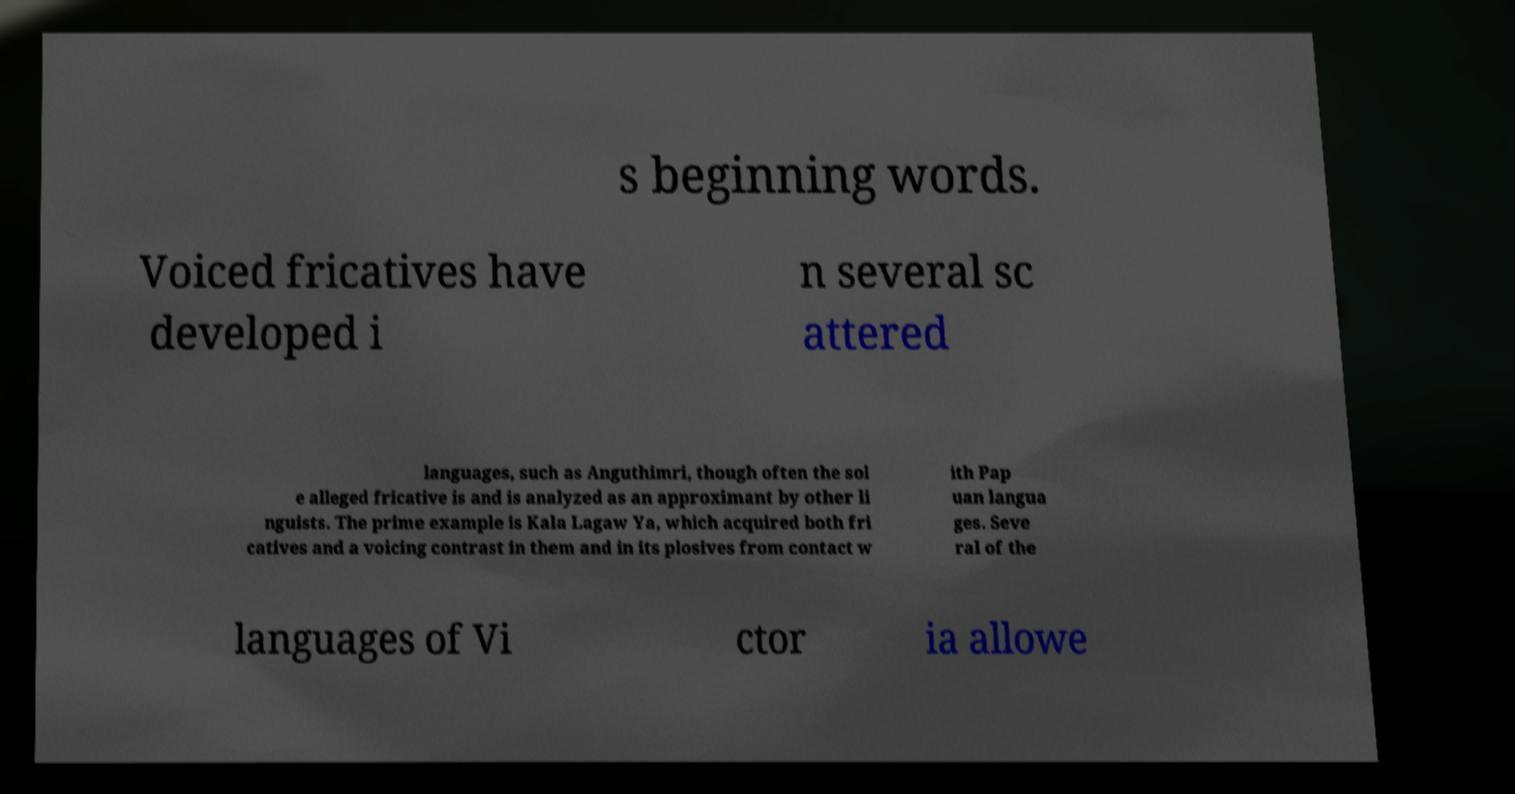What messages or text are displayed in this image? I need them in a readable, typed format. s beginning words. Voiced fricatives have developed i n several sc attered languages, such as Anguthimri, though often the sol e alleged fricative is and is analyzed as an approximant by other li nguists. The prime example is Kala Lagaw Ya, which acquired both fri catives and a voicing contrast in them and in its plosives from contact w ith Pap uan langua ges. Seve ral of the languages of Vi ctor ia allowe 